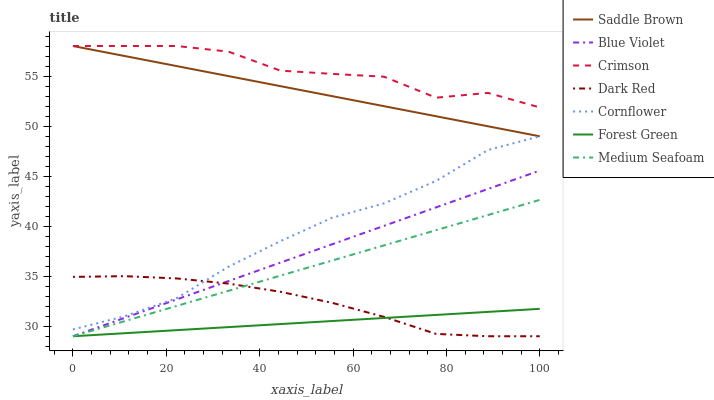Does Forest Green have the minimum area under the curve?
Answer yes or no. Yes. Does Crimson have the maximum area under the curve?
Answer yes or no. Yes. Does Dark Red have the minimum area under the curve?
Answer yes or no. No. Does Dark Red have the maximum area under the curve?
Answer yes or no. No. Is Forest Green the smoothest?
Answer yes or no. Yes. Is Crimson the roughest?
Answer yes or no. Yes. Is Dark Red the smoothest?
Answer yes or no. No. Is Dark Red the roughest?
Answer yes or no. No. Does Dark Red have the lowest value?
Answer yes or no. Yes. Does Crimson have the lowest value?
Answer yes or no. No. Does Saddle Brown have the highest value?
Answer yes or no. Yes. Does Dark Red have the highest value?
Answer yes or no. No. Is Cornflower less than Crimson?
Answer yes or no. Yes. Is Crimson greater than Medium Seafoam?
Answer yes or no. Yes. Does Cornflower intersect Dark Red?
Answer yes or no. Yes. Is Cornflower less than Dark Red?
Answer yes or no. No. Is Cornflower greater than Dark Red?
Answer yes or no. No. Does Cornflower intersect Crimson?
Answer yes or no. No. 